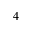<formula> <loc_0><loc_0><loc_500><loc_500>^ { 4 }</formula> 